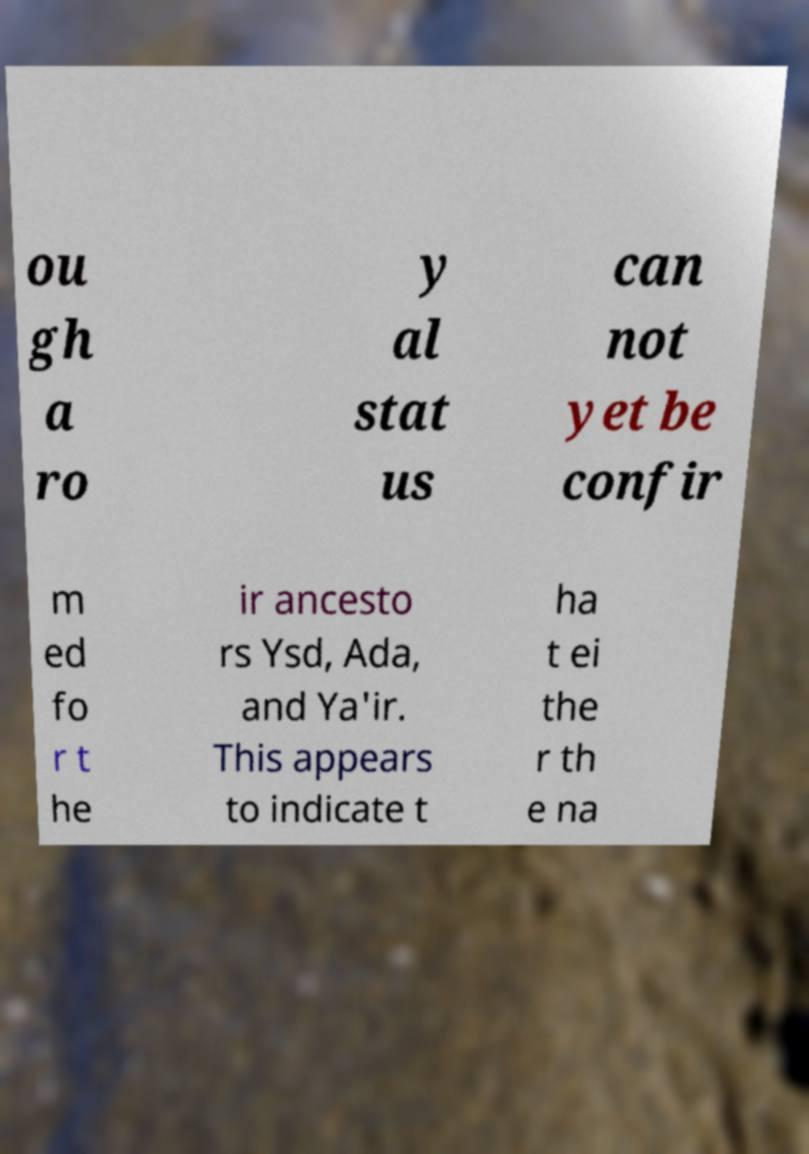Could you extract and type out the text from this image? ou gh a ro y al stat us can not yet be confir m ed fo r t he ir ancesto rs Ysd, Ada, and Ya'ir. This appears to indicate t ha t ei the r th e na 